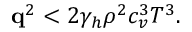<formula> <loc_0><loc_0><loc_500><loc_500>\begin{array} { r } { \mathbf q ^ { 2 } < 2 \gamma _ { h } \rho ^ { 2 } c _ { v } ^ { 3 } T ^ { 3 } . } \end{array}</formula> 